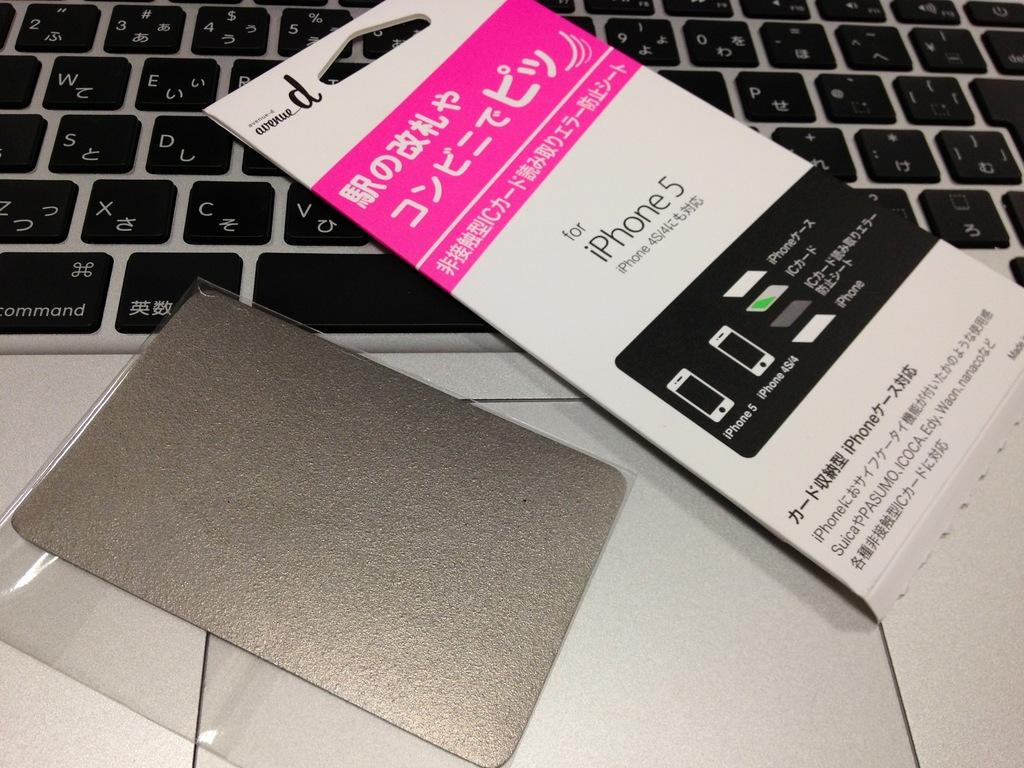Which version of the iphone is seen on the box?
Ensure brevity in your answer.  5. What two models of phone will this item fit?
Offer a terse response. Iphone 5. 